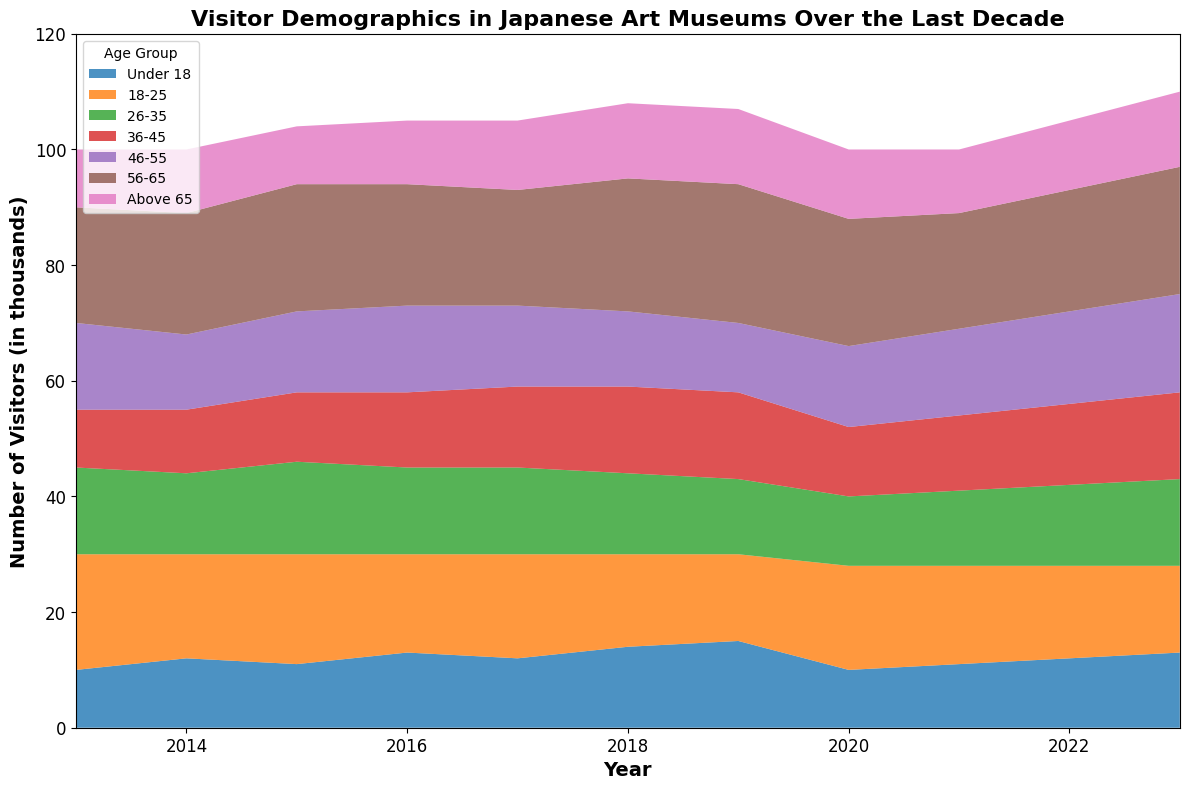What's the trend of visitors aged 56-65 over the years? Observing the area representing the 56-65 age group, the trend shows a steady increase from 2013 to 2019, followed by a slight dip in 2020, then an increase again up to 2023.
Answer: Steady increase with a slight dip in 2020 Which age group had the most significant decrease in visitors between 2019 and 2020? Comparing the areas between 2019 and 2020, the 26-35 age group shows a noticeable decrease in height compared to other groups.
Answer: 26-35 In which year did the Under 18 age group have the highest number of visitors? By inspecting the height of the Under 18 area over the years, 2019 has the tallest area for this group.
Answer: 2019 In 2023, how does the number of visitors aged 46-55 compare to those aged 36-45? In the year 2023, the area for 46-55 appears slightly taller than that of 36-45, indicating more visitors for the 46-55 group.
Answer: More for 46-55 What is the average number of visitors aged 18-25 from 2013 to 2023? Summing the visitors for 18-25 from 2013 to 2023: 20+18+19+17+18+16+15+18+17+16+15 = 189. There are 11 years, thus the average is 189/11 ≈ 17.18.
Answer: 17.18 How did the number of visitors aged Above 65 change from 2013 to 2023? Comparing the heights for Above 65 in 2013 and 2023, there is an increase in the area, signifying more visitors in 2023 than 2013.
Answer: Increased Which year had the highest total number of visitors across all age groups? Summing the areas for each year, it appears that 2019 has visually the largest combined area for all age groups.
Answer: 2019 What is the total number of visitors in 2017 for all age groups combined? Summing the visitors for all age groups in 2017: 12+18+15+14+14+20+12 = 105.
Answer: 105 Which age group consistently had more than 20,000 visitors every year? Observing the areas consistently above a certain height, the 56-65 age group has visitors above the 20,000 mark every year from 2013 to 2023.
Answer: 56-65 What is the trend for the 18-25 age group from 2013 to 2023? The visitors for 18-25 start high in 2013 and then show a slight declining trend overall from 2013 through 2023.
Answer: Slight decline 